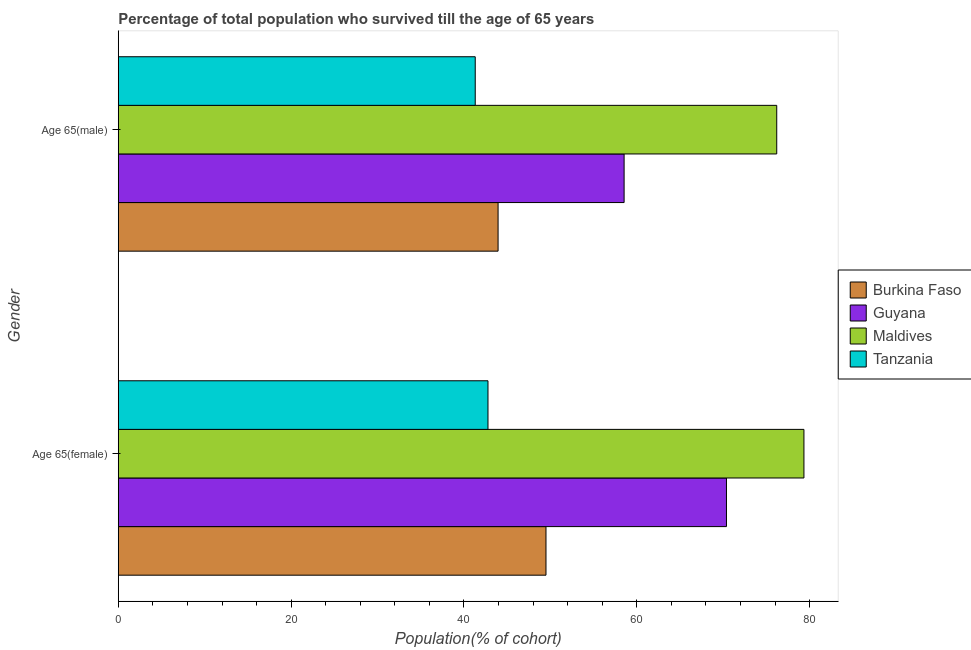How many groups of bars are there?
Offer a terse response. 2. Are the number of bars per tick equal to the number of legend labels?
Provide a succinct answer. Yes. Are the number of bars on each tick of the Y-axis equal?
Ensure brevity in your answer.  Yes. What is the label of the 2nd group of bars from the top?
Make the answer very short. Age 65(female). What is the percentage of female population who survived till age of 65 in Maldives?
Provide a short and direct response. 79.33. Across all countries, what is the maximum percentage of female population who survived till age of 65?
Provide a succinct answer. 79.33. Across all countries, what is the minimum percentage of female population who survived till age of 65?
Keep it short and to the point. 42.78. In which country was the percentage of female population who survived till age of 65 maximum?
Your response must be concise. Maldives. In which country was the percentage of male population who survived till age of 65 minimum?
Ensure brevity in your answer.  Tanzania. What is the total percentage of female population who survived till age of 65 in the graph?
Ensure brevity in your answer.  241.97. What is the difference between the percentage of female population who survived till age of 65 in Maldives and that in Burkina Faso?
Ensure brevity in your answer.  29.85. What is the difference between the percentage of male population who survived till age of 65 in Burkina Faso and the percentage of female population who survived till age of 65 in Tanzania?
Provide a short and direct response. 1.17. What is the average percentage of female population who survived till age of 65 per country?
Your response must be concise. 60.49. What is the difference between the percentage of female population who survived till age of 65 and percentage of male population who survived till age of 65 in Guyana?
Provide a succinct answer. 11.84. In how many countries, is the percentage of female population who survived till age of 65 greater than 4 %?
Ensure brevity in your answer.  4. What is the ratio of the percentage of male population who survived till age of 65 in Burkina Faso to that in Guyana?
Your answer should be very brief. 0.75. In how many countries, is the percentage of female population who survived till age of 65 greater than the average percentage of female population who survived till age of 65 taken over all countries?
Keep it short and to the point. 2. What does the 4th bar from the top in Age 65(male) represents?
Give a very brief answer. Burkina Faso. What does the 2nd bar from the bottom in Age 65(female) represents?
Offer a terse response. Guyana. How many bars are there?
Keep it short and to the point. 8. Are all the bars in the graph horizontal?
Provide a succinct answer. Yes. What is the difference between two consecutive major ticks on the X-axis?
Your answer should be compact. 20. Does the graph contain any zero values?
Provide a succinct answer. No. Does the graph contain grids?
Give a very brief answer. No. Where does the legend appear in the graph?
Provide a short and direct response. Center right. How many legend labels are there?
Provide a succinct answer. 4. What is the title of the graph?
Offer a terse response. Percentage of total population who survived till the age of 65 years. Does "Trinidad and Tobago" appear as one of the legend labels in the graph?
Ensure brevity in your answer.  No. What is the label or title of the X-axis?
Your response must be concise. Population(% of cohort). What is the Population(% of cohort) in Burkina Faso in Age 65(female)?
Offer a very short reply. 49.49. What is the Population(% of cohort) in Guyana in Age 65(female)?
Ensure brevity in your answer.  70.37. What is the Population(% of cohort) of Maldives in Age 65(female)?
Make the answer very short. 79.33. What is the Population(% of cohort) of Tanzania in Age 65(female)?
Offer a terse response. 42.78. What is the Population(% of cohort) of Burkina Faso in Age 65(male)?
Make the answer very short. 43.95. What is the Population(% of cohort) of Guyana in Age 65(male)?
Your answer should be compact. 58.53. What is the Population(% of cohort) in Maldives in Age 65(male)?
Keep it short and to the point. 76.19. What is the Population(% of cohort) in Tanzania in Age 65(male)?
Your answer should be very brief. 41.3. Across all Gender, what is the maximum Population(% of cohort) of Burkina Faso?
Give a very brief answer. 49.49. Across all Gender, what is the maximum Population(% of cohort) in Guyana?
Offer a very short reply. 70.37. Across all Gender, what is the maximum Population(% of cohort) of Maldives?
Your answer should be very brief. 79.33. Across all Gender, what is the maximum Population(% of cohort) of Tanzania?
Your answer should be very brief. 42.78. Across all Gender, what is the minimum Population(% of cohort) in Burkina Faso?
Offer a terse response. 43.95. Across all Gender, what is the minimum Population(% of cohort) of Guyana?
Ensure brevity in your answer.  58.53. Across all Gender, what is the minimum Population(% of cohort) of Maldives?
Make the answer very short. 76.19. Across all Gender, what is the minimum Population(% of cohort) in Tanzania?
Offer a very short reply. 41.3. What is the total Population(% of cohort) in Burkina Faso in the graph?
Ensure brevity in your answer.  93.43. What is the total Population(% of cohort) of Guyana in the graph?
Provide a short and direct response. 128.9. What is the total Population(% of cohort) of Maldives in the graph?
Offer a terse response. 155.52. What is the total Population(% of cohort) of Tanzania in the graph?
Offer a very short reply. 84.08. What is the difference between the Population(% of cohort) of Burkina Faso in Age 65(female) and that in Age 65(male)?
Offer a terse response. 5.54. What is the difference between the Population(% of cohort) of Guyana in Age 65(female) and that in Age 65(male)?
Provide a short and direct response. 11.84. What is the difference between the Population(% of cohort) in Maldives in Age 65(female) and that in Age 65(male)?
Ensure brevity in your answer.  3.15. What is the difference between the Population(% of cohort) of Tanzania in Age 65(female) and that in Age 65(male)?
Your response must be concise. 1.48. What is the difference between the Population(% of cohort) of Burkina Faso in Age 65(female) and the Population(% of cohort) of Guyana in Age 65(male)?
Provide a short and direct response. -9.04. What is the difference between the Population(% of cohort) in Burkina Faso in Age 65(female) and the Population(% of cohort) in Maldives in Age 65(male)?
Give a very brief answer. -26.7. What is the difference between the Population(% of cohort) of Burkina Faso in Age 65(female) and the Population(% of cohort) of Tanzania in Age 65(male)?
Provide a short and direct response. 8.19. What is the difference between the Population(% of cohort) in Guyana in Age 65(female) and the Population(% of cohort) in Maldives in Age 65(male)?
Make the answer very short. -5.82. What is the difference between the Population(% of cohort) in Guyana in Age 65(female) and the Population(% of cohort) in Tanzania in Age 65(male)?
Ensure brevity in your answer.  29.07. What is the difference between the Population(% of cohort) in Maldives in Age 65(female) and the Population(% of cohort) in Tanzania in Age 65(male)?
Your answer should be very brief. 38.03. What is the average Population(% of cohort) of Burkina Faso per Gender?
Your answer should be compact. 46.72. What is the average Population(% of cohort) of Guyana per Gender?
Offer a terse response. 64.45. What is the average Population(% of cohort) of Maldives per Gender?
Provide a succinct answer. 77.76. What is the average Population(% of cohort) in Tanzania per Gender?
Give a very brief answer. 42.04. What is the difference between the Population(% of cohort) in Burkina Faso and Population(% of cohort) in Guyana in Age 65(female)?
Give a very brief answer. -20.88. What is the difference between the Population(% of cohort) of Burkina Faso and Population(% of cohort) of Maldives in Age 65(female)?
Provide a short and direct response. -29.85. What is the difference between the Population(% of cohort) of Burkina Faso and Population(% of cohort) of Tanzania in Age 65(female)?
Your response must be concise. 6.71. What is the difference between the Population(% of cohort) of Guyana and Population(% of cohort) of Maldives in Age 65(female)?
Offer a very short reply. -8.96. What is the difference between the Population(% of cohort) of Guyana and Population(% of cohort) of Tanzania in Age 65(female)?
Offer a terse response. 27.59. What is the difference between the Population(% of cohort) of Maldives and Population(% of cohort) of Tanzania in Age 65(female)?
Provide a succinct answer. 36.56. What is the difference between the Population(% of cohort) in Burkina Faso and Population(% of cohort) in Guyana in Age 65(male)?
Your answer should be very brief. -14.58. What is the difference between the Population(% of cohort) in Burkina Faso and Population(% of cohort) in Maldives in Age 65(male)?
Your answer should be compact. -32.24. What is the difference between the Population(% of cohort) in Burkina Faso and Population(% of cohort) in Tanzania in Age 65(male)?
Your response must be concise. 2.64. What is the difference between the Population(% of cohort) of Guyana and Population(% of cohort) of Maldives in Age 65(male)?
Keep it short and to the point. -17.66. What is the difference between the Population(% of cohort) of Guyana and Population(% of cohort) of Tanzania in Age 65(male)?
Ensure brevity in your answer.  17.23. What is the difference between the Population(% of cohort) in Maldives and Population(% of cohort) in Tanzania in Age 65(male)?
Ensure brevity in your answer.  34.89. What is the ratio of the Population(% of cohort) of Burkina Faso in Age 65(female) to that in Age 65(male)?
Offer a terse response. 1.13. What is the ratio of the Population(% of cohort) of Guyana in Age 65(female) to that in Age 65(male)?
Provide a succinct answer. 1.2. What is the ratio of the Population(% of cohort) of Maldives in Age 65(female) to that in Age 65(male)?
Provide a succinct answer. 1.04. What is the ratio of the Population(% of cohort) in Tanzania in Age 65(female) to that in Age 65(male)?
Keep it short and to the point. 1.04. What is the difference between the highest and the second highest Population(% of cohort) of Burkina Faso?
Give a very brief answer. 5.54. What is the difference between the highest and the second highest Population(% of cohort) of Guyana?
Your answer should be compact. 11.84. What is the difference between the highest and the second highest Population(% of cohort) of Maldives?
Your answer should be very brief. 3.15. What is the difference between the highest and the second highest Population(% of cohort) in Tanzania?
Your response must be concise. 1.48. What is the difference between the highest and the lowest Population(% of cohort) of Burkina Faso?
Offer a terse response. 5.54. What is the difference between the highest and the lowest Population(% of cohort) in Guyana?
Provide a short and direct response. 11.84. What is the difference between the highest and the lowest Population(% of cohort) in Maldives?
Offer a very short reply. 3.15. What is the difference between the highest and the lowest Population(% of cohort) of Tanzania?
Provide a succinct answer. 1.48. 